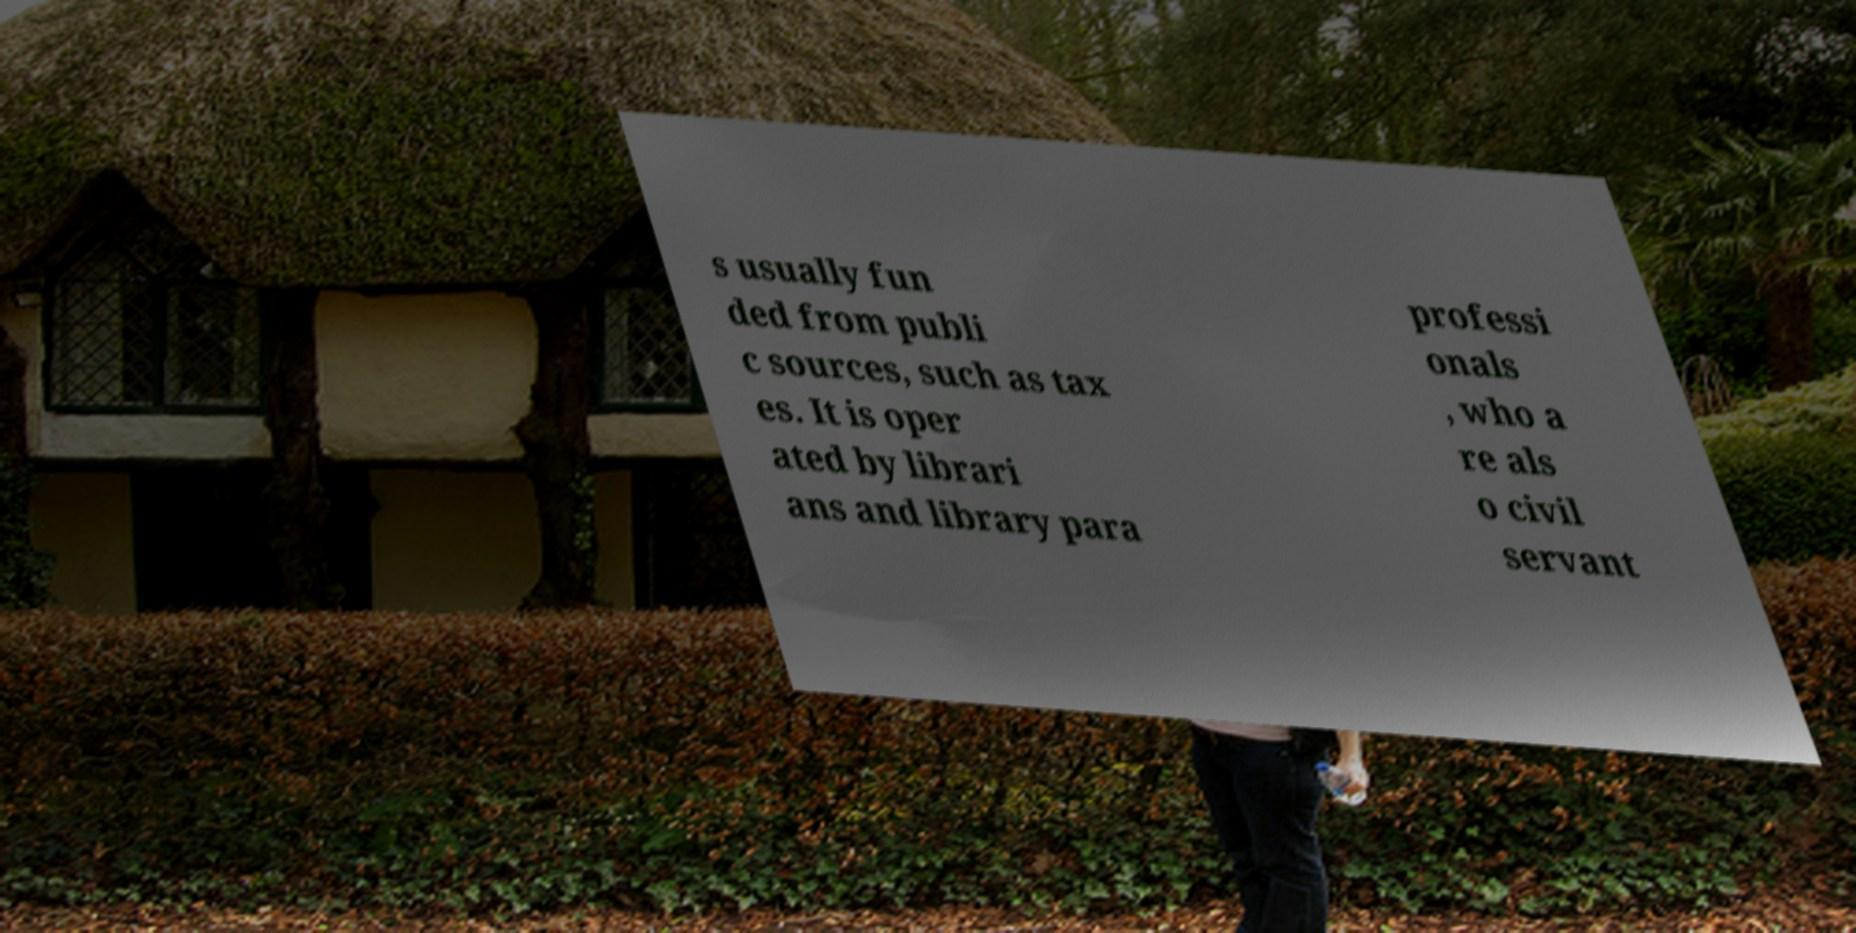Can you read and provide the text displayed in the image?This photo seems to have some interesting text. Can you extract and type it out for me? s usually fun ded from publi c sources, such as tax es. It is oper ated by librari ans and library para professi onals , who a re als o civil servant 